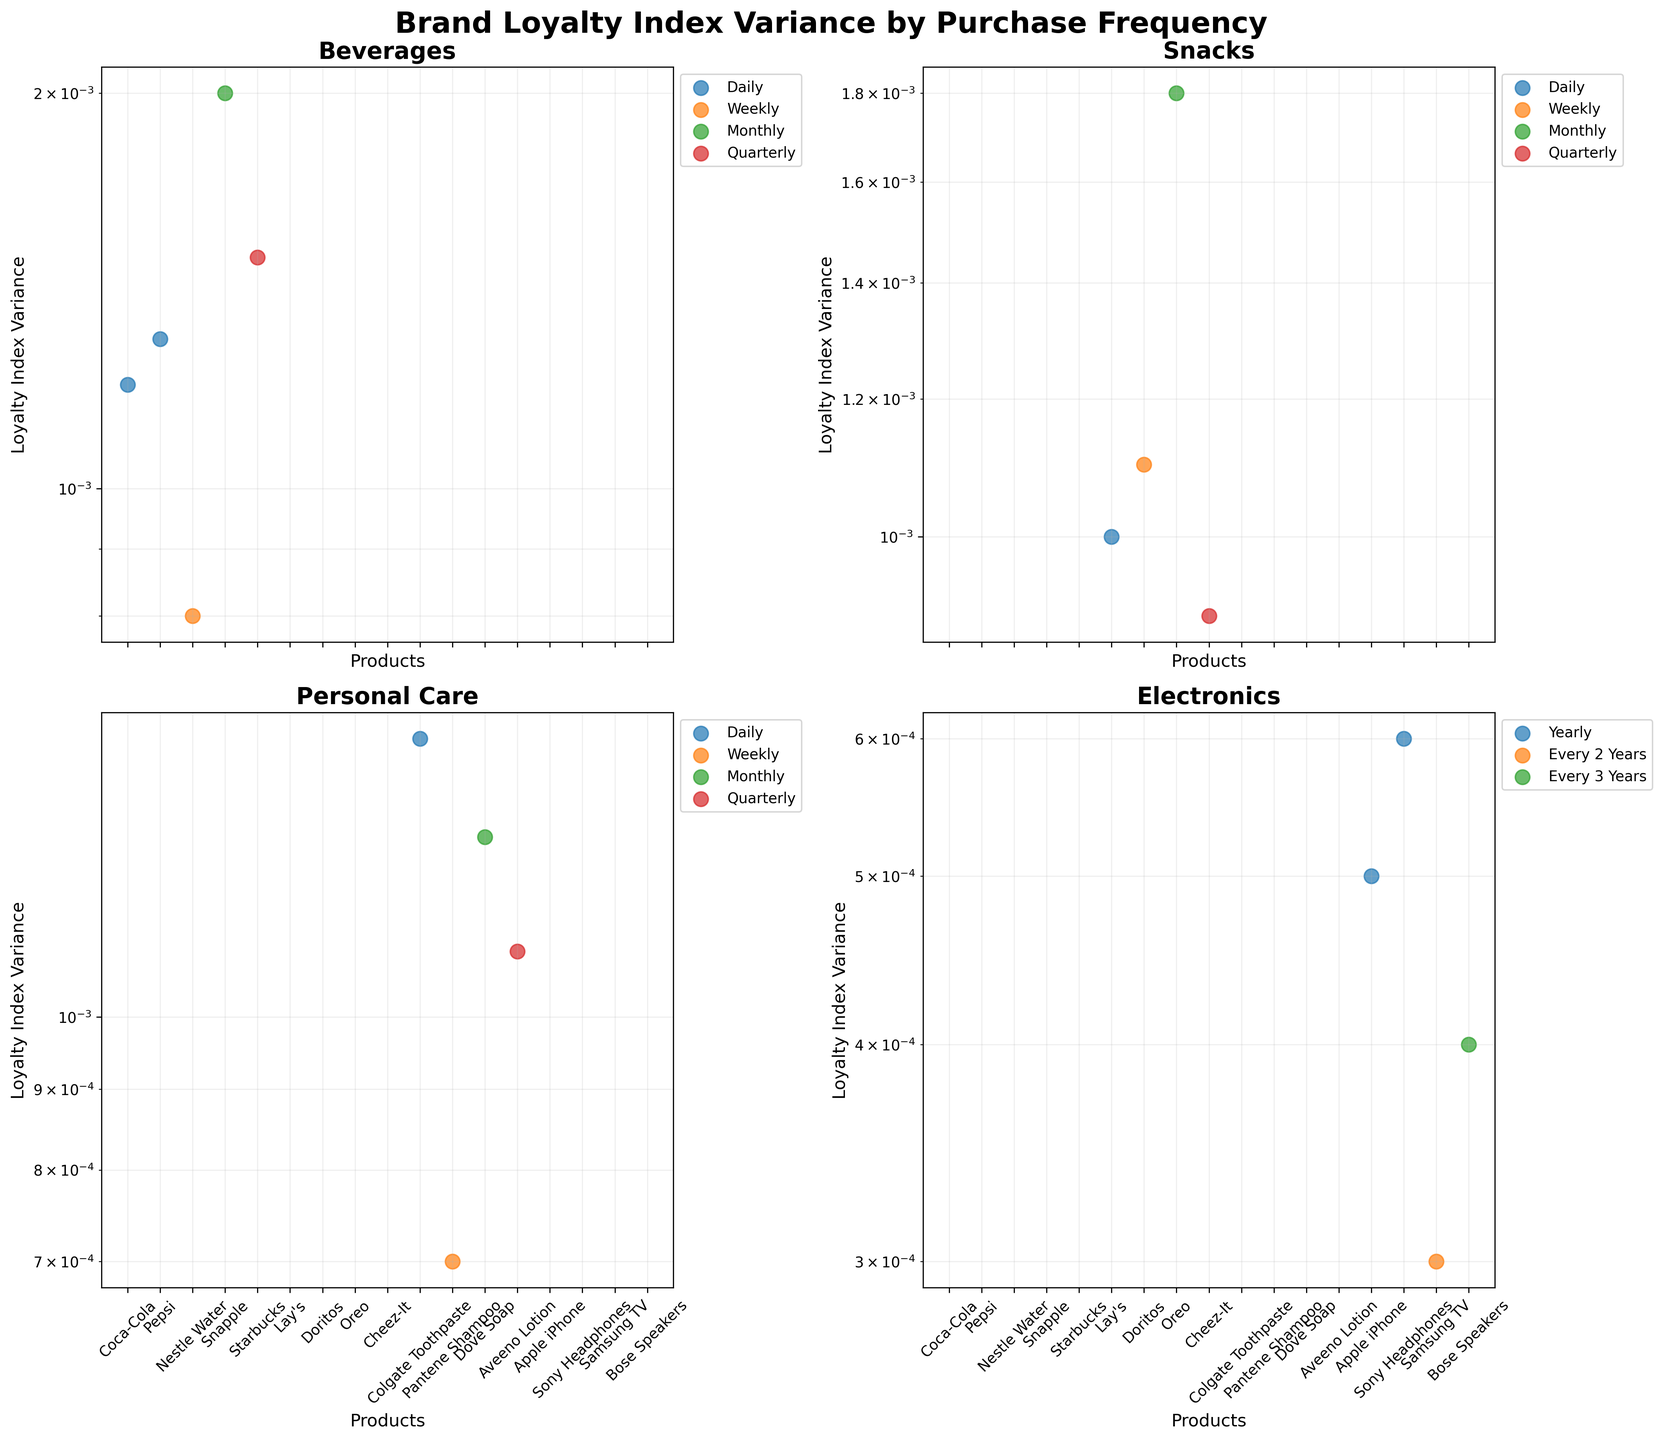How many consumer product categories are represented in the figure? There are four subplots in the figure, each representing a unique consumer product category.
Answer: Four Which consumer product category has the highest loyalty index variance for a product bought on a daily basis? In the subplot for each category, the highest loyalty index variance for daily purchases can be identified. Coca-Cola has a variance of 1.2e-3 in Beverages, Lay's has a variance of 1.0e-3 in Snacks, Colgate Toothpaste has a variance of 1.5e-3 in Personal Care, and there are no daily purchases in Electronics. Colgate Toothpaste's variance of 1.5e-3 in Personal Care is the highest.
Answer: Personal Care What's the median loyalty index variance for products in the Beverages category? For Beverages, the loyalty index variances are 1.2e-3, 1.3e-3, 0.8e-3, 2.0e-3, and 1.5e-3. Arrange them: 0.8e-3, 1.2e-3, 1.3e-3, 1.5e-3, 2.0e-3. The median is the middle value, 1.3e-3.
Answer: 1.3e-3 Which product has the lowest loyalty index variance in the Electronics category? In the Electronics subplot, the lowest variance can be identified by comparing values: Apple iPhone (0.5e-3), Samsung TV (0.3e-3), Sony Headphones (0.6e-3), and Bose Speakers (0.4e-3). Samsung TV has the lowest variance at 0.3e-3.
Answer: Samsung TV What is the range of loyalty index variance values for the Snacks category? The range is calculated by subtracting the smallest variance from the largest variance in the Snacks category. Variances are: Lay's (1.0e-3), Doritos (1.1e-3), Oreo (1.8e-3), Cheez-It (0.9e-3). The range is 1.8e-3 - 0.9e-3 = 0.9e-3.
Answer: 0.9e-3 How do the loyalty index variances for Starbucks (Beverages) and Aveeno Lotion (Personal Care) compare on a log scale? By observing the subplot with log-scaled y-axis, the points for Starbucks (1.5e-3) and Aveeno Lotion (1.1e-3) indicate that Starbucks has a higher loyalty variance than Aveeno Lotion, as 1.5e-3 is greater than 1.1e-3.
Answer: Starbucks > Aveeno Lotion Which product has the highest loyalty index variance in the Beverages category? By checking the scatter points in the Beverages subplot, Snapple has the highest variance at 2.0e-3.
Answer: Snapple Is the loyalty index variance for Dove Soap higher than for Nestle Water? In the respective subplots for Beverages (Nestle Water: 0.8e-3) and Personal Care (Dove Soap: 1.3e-3), Dove Soap has a higher loyalty index variance than Nestle Water.
Answer: Yes Does any product in the Snacks category have a lower loyalty index variance than any product in the Personal Care category? In the Snacks subplot, the lowest variance is Cheez-It (0.9e-3). In Personal Care, the lowest variance is Pantene Shampoo (0.7e-3). Since Pantene Shampoo's variance is lower, none of the Snacks products have a lower variance.
Answer: No 